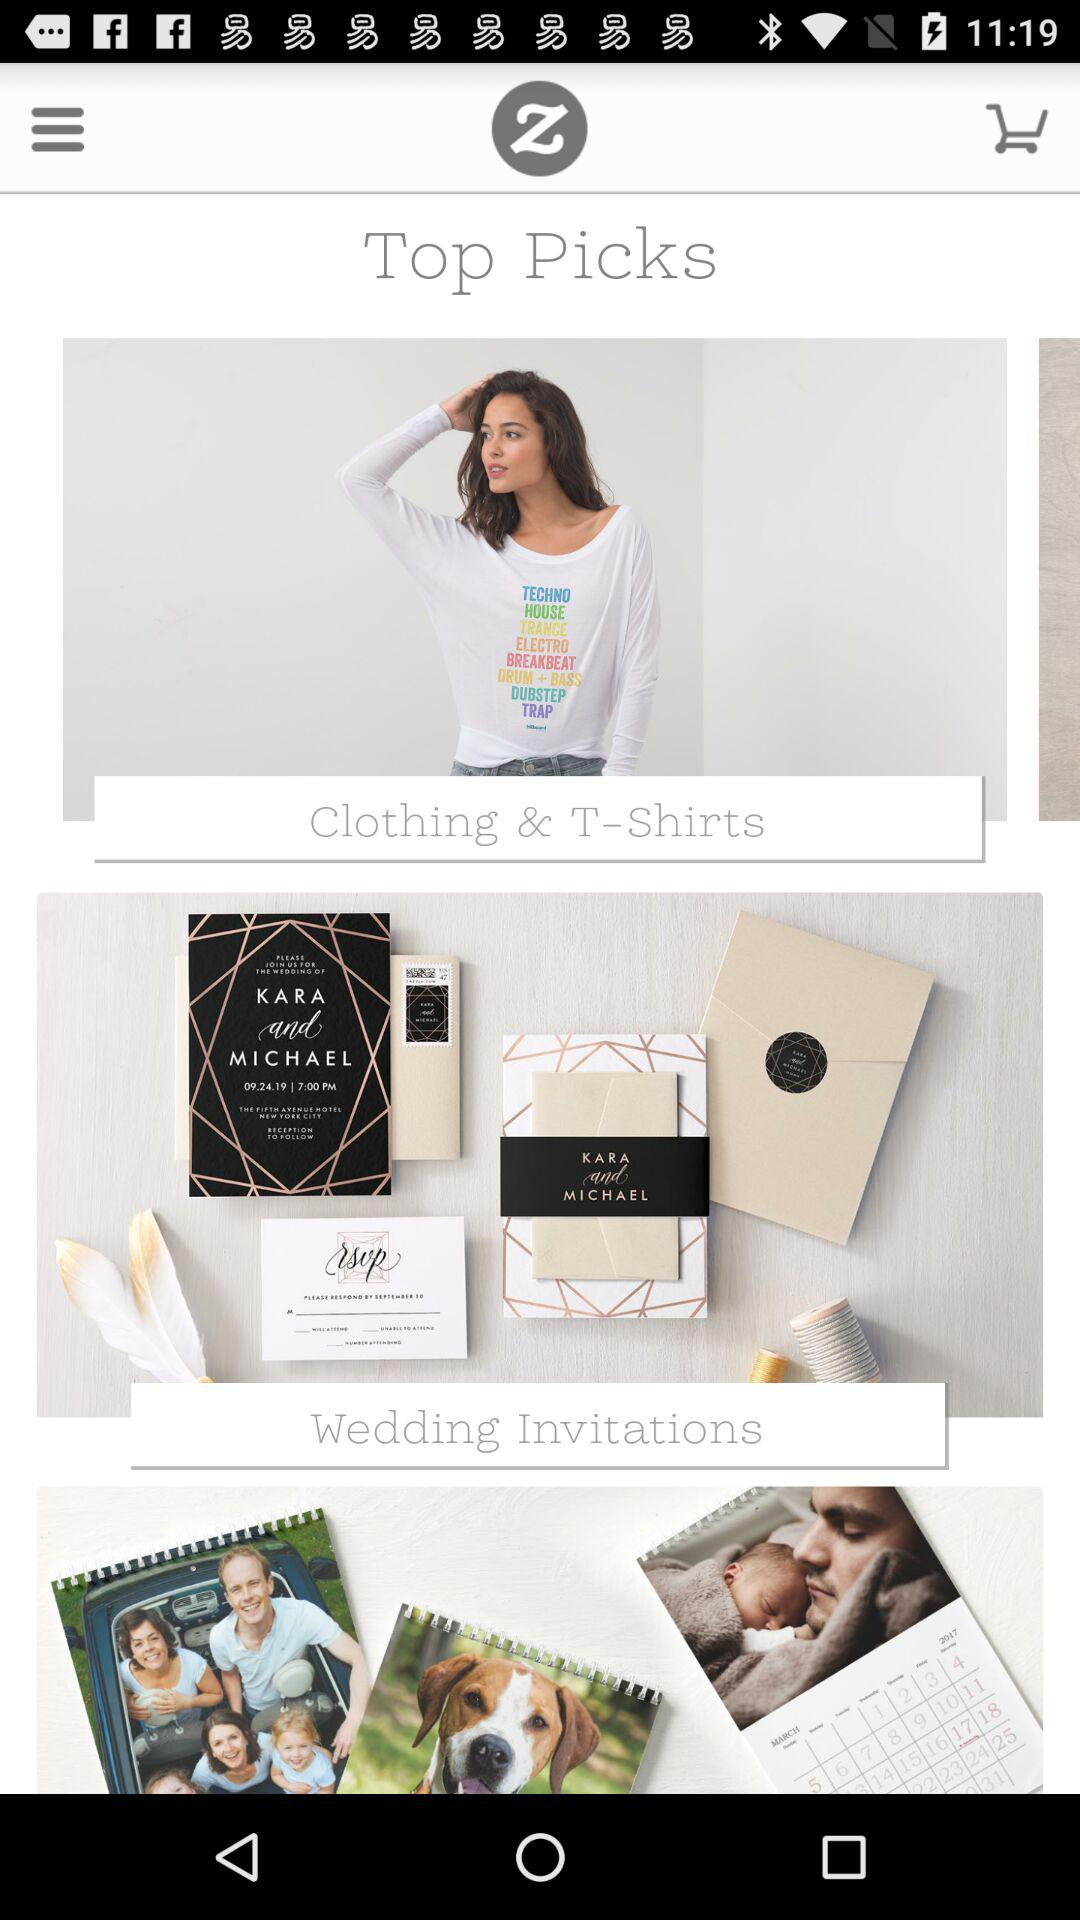How many items are there on the page that have a text label?
Answer the question using a single word or phrase. 3 